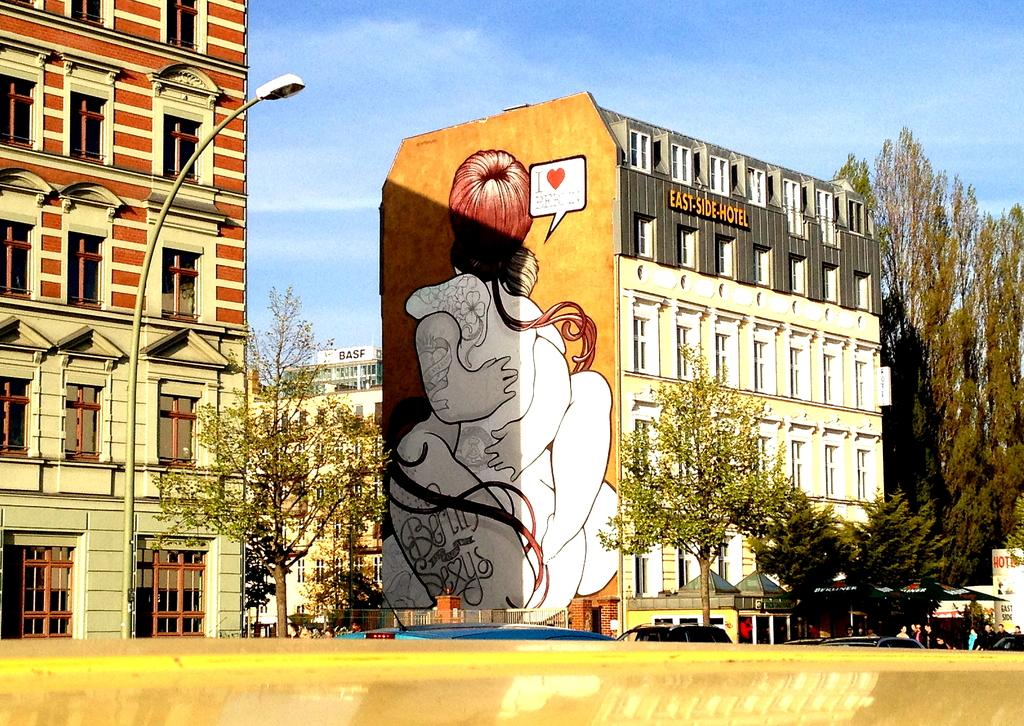What type of structures can be seen in the background of the image? There are buildings in the background of the image. What is located in front of the buildings? There are trees in front of the buildings. What mode of transportation can be seen on the road in the image? There are cars on the road in the image. What part of the natural environment is visible in the image? The sky is visible in the image. What can be observed in the sky? Clouds are present in the sky. What type of yam is being used to make a connection between the railway tracks in the image? There is no yam or railway tracks present in the image. How does the yam help in maintaining the railway connection in the image? There is no yam or railway connection present in the image, so this question cannot be answered. 